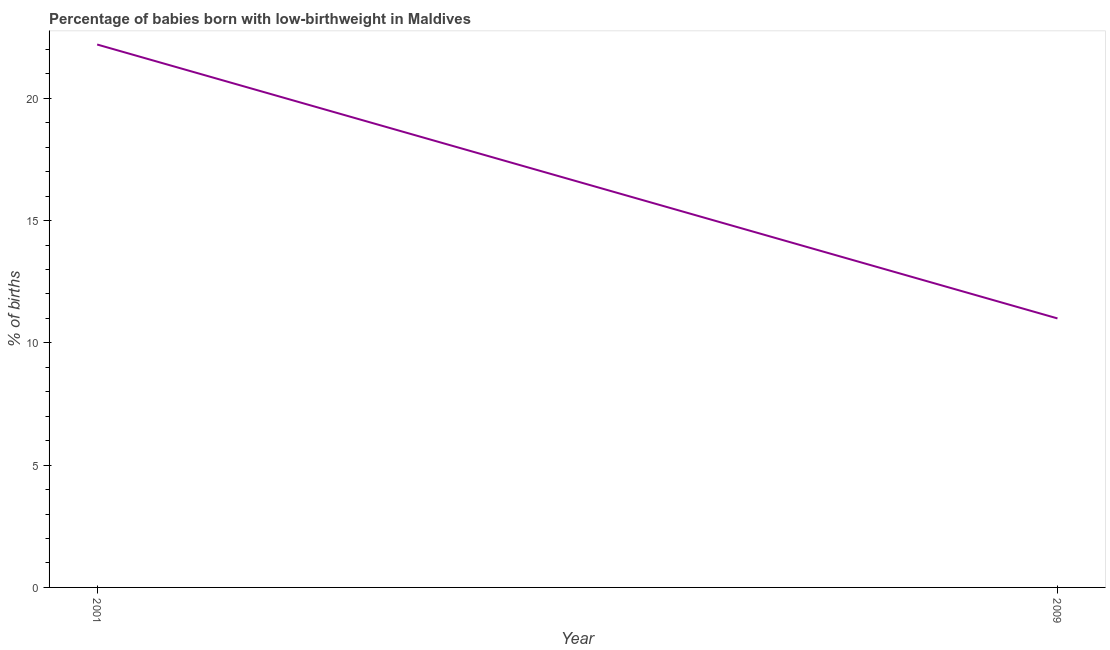What is the percentage of babies who were born with low-birthweight in 2009?
Provide a short and direct response. 11. In which year was the percentage of babies who were born with low-birthweight maximum?
Offer a very short reply. 2001. What is the sum of the percentage of babies who were born with low-birthweight?
Ensure brevity in your answer.  33.2. What is the average percentage of babies who were born with low-birthweight per year?
Your answer should be very brief. 16.6. What is the ratio of the percentage of babies who were born with low-birthweight in 2001 to that in 2009?
Keep it short and to the point. 2.02. Does the percentage of babies who were born with low-birthweight monotonically increase over the years?
Provide a short and direct response. No. Are the values on the major ticks of Y-axis written in scientific E-notation?
Offer a terse response. No. What is the title of the graph?
Keep it short and to the point. Percentage of babies born with low-birthweight in Maldives. What is the label or title of the X-axis?
Offer a terse response. Year. What is the label or title of the Y-axis?
Provide a short and direct response. % of births. What is the % of births in 2001?
Your response must be concise. 22.2. What is the % of births in 2009?
Your response must be concise. 11. What is the ratio of the % of births in 2001 to that in 2009?
Your response must be concise. 2.02. 